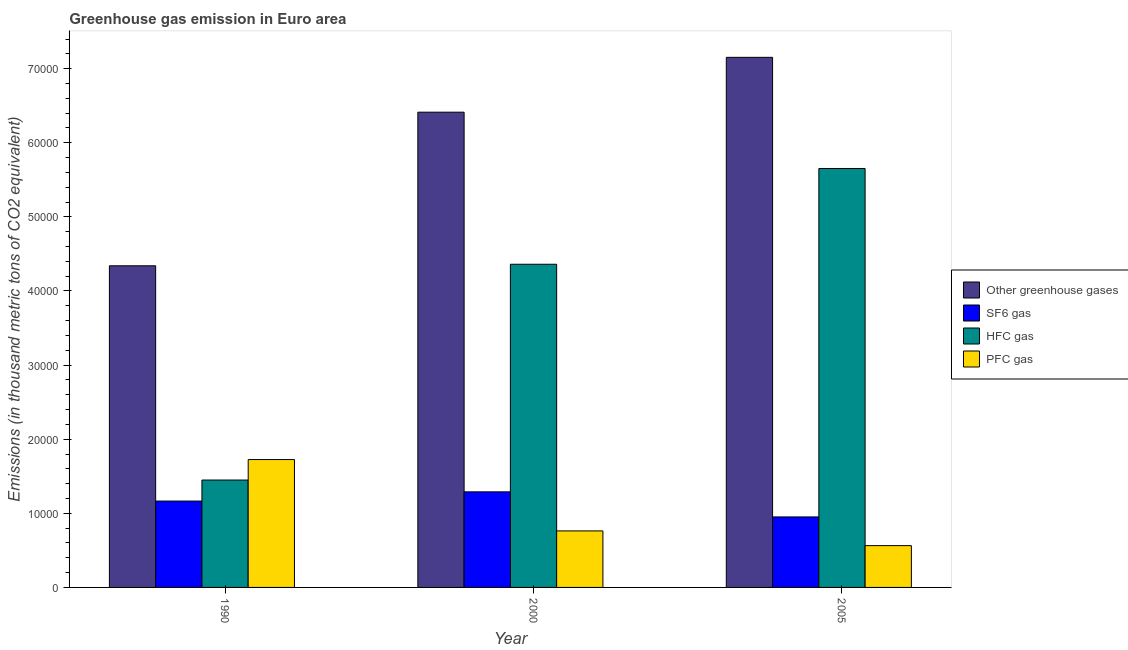Are the number of bars per tick equal to the number of legend labels?
Your answer should be compact. Yes. Are the number of bars on each tick of the X-axis equal?
Keep it short and to the point. Yes. What is the label of the 1st group of bars from the left?
Provide a succinct answer. 1990. In how many cases, is the number of bars for a given year not equal to the number of legend labels?
Your response must be concise. 0. What is the emission of hfc gas in 1990?
Your response must be concise. 1.45e+04. Across all years, what is the maximum emission of greenhouse gases?
Your answer should be very brief. 7.15e+04. Across all years, what is the minimum emission of greenhouse gases?
Your response must be concise. 4.34e+04. In which year was the emission of pfc gas maximum?
Your answer should be compact. 1990. In which year was the emission of hfc gas minimum?
Make the answer very short. 1990. What is the total emission of sf6 gas in the graph?
Provide a succinct answer. 3.41e+04. What is the difference between the emission of sf6 gas in 1990 and that in 2005?
Ensure brevity in your answer.  2140.88. What is the difference between the emission of greenhouse gases in 2005 and the emission of pfc gas in 1990?
Your answer should be compact. 2.81e+04. What is the average emission of greenhouse gases per year?
Your answer should be very brief. 5.97e+04. In how many years, is the emission of pfc gas greater than 22000 thousand metric tons?
Your answer should be very brief. 0. What is the ratio of the emission of sf6 gas in 1990 to that in 2000?
Keep it short and to the point. 0.9. Is the emission of hfc gas in 1990 less than that in 2000?
Offer a terse response. Yes. Is the difference between the emission of hfc gas in 1990 and 2005 greater than the difference between the emission of pfc gas in 1990 and 2005?
Your response must be concise. No. What is the difference between the highest and the second highest emission of hfc gas?
Provide a short and direct response. 1.29e+04. What is the difference between the highest and the lowest emission of greenhouse gases?
Your response must be concise. 2.81e+04. In how many years, is the emission of pfc gas greater than the average emission of pfc gas taken over all years?
Provide a short and direct response. 1. What does the 2nd bar from the left in 2000 represents?
Offer a terse response. SF6 gas. What does the 2nd bar from the right in 2005 represents?
Keep it short and to the point. HFC gas. How many years are there in the graph?
Your answer should be compact. 3. Does the graph contain any zero values?
Provide a short and direct response. No. Does the graph contain grids?
Give a very brief answer. No. Where does the legend appear in the graph?
Provide a succinct answer. Center right. How are the legend labels stacked?
Give a very brief answer. Vertical. What is the title of the graph?
Offer a terse response. Greenhouse gas emission in Euro area. Does "Public resource use" appear as one of the legend labels in the graph?
Make the answer very short. No. What is the label or title of the X-axis?
Offer a terse response. Year. What is the label or title of the Y-axis?
Keep it short and to the point. Emissions (in thousand metric tons of CO2 equivalent). What is the Emissions (in thousand metric tons of CO2 equivalent) in Other greenhouse gases in 1990?
Your response must be concise. 4.34e+04. What is the Emissions (in thousand metric tons of CO2 equivalent) of SF6 gas in 1990?
Ensure brevity in your answer.  1.17e+04. What is the Emissions (in thousand metric tons of CO2 equivalent) of HFC gas in 1990?
Offer a terse response. 1.45e+04. What is the Emissions (in thousand metric tons of CO2 equivalent) in PFC gas in 1990?
Your response must be concise. 1.73e+04. What is the Emissions (in thousand metric tons of CO2 equivalent) of Other greenhouse gases in 2000?
Your answer should be very brief. 6.41e+04. What is the Emissions (in thousand metric tons of CO2 equivalent) in SF6 gas in 2000?
Offer a terse response. 1.29e+04. What is the Emissions (in thousand metric tons of CO2 equivalent) of HFC gas in 2000?
Make the answer very short. 4.36e+04. What is the Emissions (in thousand metric tons of CO2 equivalent) of PFC gas in 2000?
Your answer should be very brief. 7625. What is the Emissions (in thousand metric tons of CO2 equivalent) in Other greenhouse gases in 2005?
Provide a short and direct response. 7.15e+04. What is the Emissions (in thousand metric tons of CO2 equivalent) of SF6 gas in 2005?
Offer a very short reply. 9513.72. What is the Emissions (in thousand metric tons of CO2 equivalent) of HFC gas in 2005?
Your response must be concise. 5.65e+04. What is the Emissions (in thousand metric tons of CO2 equivalent) in PFC gas in 2005?
Provide a succinct answer. 5640.06. Across all years, what is the maximum Emissions (in thousand metric tons of CO2 equivalent) of Other greenhouse gases?
Provide a short and direct response. 7.15e+04. Across all years, what is the maximum Emissions (in thousand metric tons of CO2 equivalent) of SF6 gas?
Make the answer very short. 1.29e+04. Across all years, what is the maximum Emissions (in thousand metric tons of CO2 equivalent) in HFC gas?
Offer a very short reply. 5.65e+04. Across all years, what is the maximum Emissions (in thousand metric tons of CO2 equivalent) of PFC gas?
Offer a very short reply. 1.73e+04. Across all years, what is the minimum Emissions (in thousand metric tons of CO2 equivalent) in Other greenhouse gases?
Offer a very short reply. 4.34e+04. Across all years, what is the minimum Emissions (in thousand metric tons of CO2 equivalent) of SF6 gas?
Offer a very short reply. 9513.72. Across all years, what is the minimum Emissions (in thousand metric tons of CO2 equivalent) in HFC gas?
Provide a succinct answer. 1.45e+04. Across all years, what is the minimum Emissions (in thousand metric tons of CO2 equivalent) in PFC gas?
Keep it short and to the point. 5640.06. What is the total Emissions (in thousand metric tons of CO2 equivalent) in Other greenhouse gases in the graph?
Your answer should be very brief. 1.79e+05. What is the total Emissions (in thousand metric tons of CO2 equivalent) in SF6 gas in the graph?
Offer a very short reply. 3.41e+04. What is the total Emissions (in thousand metric tons of CO2 equivalent) of HFC gas in the graph?
Your answer should be very brief. 1.15e+05. What is the total Emissions (in thousand metric tons of CO2 equivalent) in PFC gas in the graph?
Offer a very short reply. 3.05e+04. What is the difference between the Emissions (in thousand metric tons of CO2 equivalent) of Other greenhouse gases in 1990 and that in 2000?
Offer a very short reply. -2.07e+04. What is the difference between the Emissions (in thousand metric tons of CO2 equivalent) in SF6 gas in 1990 and that in 2000?
Offer a very short reply. -1242.6. What is the difference between the Emissions (in thousand metric tons of CO2 equivalent) in HFC gas in 1990 and that in 2000?
Offer a terse response. -2.91e+04. What is the difference between the Emissions (in thousand metric tons of CO2 equivalent) in PFC gas in 1990 and that in 2000?
Offer a very short reply. 9630.1. What is the difference between the Emissions (in thousand metric tons of CO2 equivalent) in Other greenhouse gases in 1990 and that in 2005?
Your response must be concise. -2.81e+04. What is the difference between the Emissions (in thousand metric tons of CO2 equivalent) of SF6 gas in 1990 and that in 2005?
Keep it short and to the point. 2140.88. What is the difference between the Emissions (in thousand metric tons of CO2 equivalent) of HFC gas in 1990 and that in 2005?
Offer a very short reply. -4.20e+04. What is the difference between the Emissions (in thousand metric tons of CO2 equivalent) of PFC gas in 1990 and that in 2005?
Offer a terse response. 1.16e+04. What is the difference between the Emissions (in thousand metric tons of CO2 equivalent) of Other greenhouse gases in 2000 and that in 2005?
Provide a succinct answer. -7401.3. What is the difference between the Emissions (in thousand metric tons of CO2 equivalent) in SF6 gas in 2000 and that in 2005?
Keep it short and to the point. 3383.48. What is the difference between the Emissions (in thousand metric tons of CO2 equivalent) of HFC gas in 2000 and that in 2005?
Ensure brevity in your answer.  -1.29e+04. What is the difference between the Emissions (in thousand metric tons of CO2 equivalent) of PFC gas in 2000 and that in 2005?
Offer a terse response. 1984.94. What is the difference between the Emissions (in thousand metric tons of CO2 equivalent) of Other greenhouse gases in 1990 and the Emissions (in thousand metric tons of CO2 equivalent) of SF6 gas in 2000?
Ensure brevity in your answer.  3.05e+04. What is the difference between the Emissions (in thousand metric tons of CO2 equivalent) of Other greenhouse gases in 1990 and the Emissions (in thousand metric tons of CO2 equivalent) of HFC gas in 2000?
Give a very brief answer. -206.3. What is the difference between the Emissions (in thousand metric tons of CO2 equivalent) in Other greenhouse gases in 1990 and the Emissions (in thousand metric tons of CO2 equivalent) in PFC gas in 2000?
Your response must be concise. 3.58e+04. What is the difference between the Emissions (in thousand metric tons of CO2 equivalent) in SF6 gas in 1990 and the Emissions (in thousand metric tons of CO2 equivalent) in HFC gas in 2000?
Give a very brief answer. -3.20e+04. What is the difference between the Emissions (in thousand metric tons of CO2 equivalent) in SF6 gas in 1990 and the Emissions (in thousand metric tons of CO2 equivalent) in PFC gas in 2000?
Offer a very short reply. 4029.6. What is the difference between the Emissions (in thousand metric tons of CO2 equivalent) in HFC gas in 1990 and the Emissions (in thousand metric tons of CO2 equivalent) in PFC gas in 2000?
Make the answer very short. 6866.6. What is the difference between the Emissions (in thousand metric tons of CO2 equivalent) of Other greenhouse gases in 1990 and the Emissions (in thousand metric tons of CO2 equivalent) of SF6 gas in 2005?
Make the answer very short. 3.39e+04. What is the difference between the Emissions (in thousand metric tons of CO2 equivalent) of Other greenhouse gases in 1990 and the Emissions (in thousand metric tons of CO2 equivalent) of HFC gas in 2005?
Your response must be concise. -1.31e+04. What is the difference between the Emissions (in thousand metric tons of CO2 equivalent) of Other greenhouse gases in 1990 and the Emissions (in thousand metric tons of CO2 equivalent) of PFC gas in 2005?
Provide a short and direct response. 3.78e+04. What is the difference between the Emissions (in thousand metric tons of CO2 equivalent) of SF6 gas in 1990 and the Emissions (in thousand metric tons of CO2 equivalent) of HFC gas in 2005?
Your answer should be very brief. -4.49e+04. What is the difference between the Emissions (in thousand metric tons of CO2 equivalent) of SF6 gas in 1990 and the Emissions (in thousand metric tons of CO2 equivalent) of PFC gas in 2005?
Your response must be concise. 6014.54. What is the difference between the Emissions (in thousand metric tons of CO2 equivalent) in HFC gas in 1990 and the Emissions (in thousand metric tons of CO2 equivalent) in PFC gas in 2005?
Give a very brief answer. 8851.54. What is the difference between the Emissions (in thousand metric tons of CO2 equivalent) in Other greenhouse gases in 2000 and the Emissions (in thousand metric tons of CO2 equivalent) in SF6 gas in 2005?
Your response must be concise. 5.46e+04. What is the difference between the Emissions (in thousand metric tons of CO2 equivalent) in Other greenhouse gases in 2000 and the Emissions (in thousand metric tons of CO2 equivalent) in HFC gas in 2005?
Make the answer very short. 7598.1. What is the difference between the Emissions (in thousand metric tons of CO2 equivalent) of Other greenhouse gases in 2000 and the Emissions (in thousand metric tons of CO2 equivalent) of PFC gas in 2005?
Provide a short and direct response. 5.85e+04. What is the difference between the Emissions (in thousand metric tons of CO2 equivalent) of SF6 gas in 2000 and the Emissions (in thousand metric tons of CO2 equivalent) of HFC gas in 2005?
Provide a short and direct response. -4.36e+04. What is the difference between the Emissions (in thousand metric tons of CO2 equivalent) in SF6 gas in 2000 and the Emissions (in thousand metric tons of CO2 equivalent) in PFC gas in 2005?
Give a very brief answer. 7257.14. What is the difference between the Emissions (in thousand metric tons of CO2 equivalent) of HFC gas in 2000 and the Emissions (in thousand metric tons of CO2 equivalent) of PFC gas in 2005?
Your answer should be very brief. 3.80e+04. What is the average Emissions (in thousand metric tons of CO2 equivalent) in Other greenhouse gases per year?
Provide a succinct answer. 5.97e+04. What is the average Emissions (in thousand metric tons of CO2 equivalent) in SF6 gas per year?
Your response must be concise. 1.14e+04. What is the average Emissions (in thousand metric tons of CO2 equivalent) of HFC gas per year?
Give a very brief answer. 3.82e+04. What is the average Emissions (in thousand metric tons of CO2 equivalent) of PFC gas per year?
Give a very brief answer. 1.02e+04. In the year 1990, what is the difference between the Emissions (in thousand metric tons of CO2 equivalent) of Other greenhouse gases and Emissions (in thousand metric tons of CO2 equivalent) of SF6 gas?
Provide a succinct answer. 3.17e+04. In the year 1990, what is the difference between the Emissions (in thousand metric tons of CO2 equivalent) in Other greenhouse gases and Emissions (in thousand metric tons of CO2 equivalent) in HFC gas?
Ensure brevity in your answer.  2.89e+04. In the year 1990, what is the difference between the Emissions (in thousand metric tons of CO2 equivalent) in Other greenhouse gases and Emissions (in thousand metric tons of CO2 equivalent) in PFC gas?
Ensure brevity in your answer.  2.61e+04. In the year 1990, what is the difference between the Emissions (in thousand metric tons of CO2 equivalent) of SF6 gas and Emissions (in thousand metric tons of CO2 equivalent) of HFC gas?
Give a very brief answer. -2837. In the year 1990, what is the difference between the Emissions (in thousand metric tons of CO2 equivalent) of SF6 gas and Emissions (in thousand metric tons of CO2 equivalent) of PFC gas?
Provide a succinct answer. -5600.5. In the year 1990, what is the difference between the Emissions (in thousand metric tons of CO2 equivalent) of HFC gas and Emissions (in thousand metric tons of CO2 equivalent) of PFC gas?
Keep it short and to the point. -2763.5. In the year 2000, what is the difference between the Emissions (in thousand metric tons of CO2 equivalent) of Other greenhouse gases and Emissions (in thousand metric tons of CO2 equivalent) of SF6 gas?
Provide a short and direct response. 5.12e+04. In the year 2000, what is the difference between the Emissions (in thousand metric tons of CO2 equivalent) of Other greenhouse gases and Emissions (in thousand metric tons of CO2 equivalent) of HFC gas?
Offer a very short reply. 2.05e+04. In the year 2000, what is the difference between the Emissions (in thousand metric tons of CO2 equivalent) in Other greenhouse gases and Emissions (in thousand metric tons of CO2 equivalent) in PFC gas?
Make the answer very short. 5.65e+04. In the year 2000, what is the difference between the Emissions (in thousand metric tons of CO2 equivalent) in SF6 gas and Emissions (in thousand metric tons of CO2 equivalent) in HFC gas?
Provide a succinct answer. -3.07e+04. In the year 2000, what is the difference between the Emissions (in thousand metric tons of CO2 equivalent) of SF6 gas and Emissions (in thousand metric tons of CO2 equivalent) of PFC gas?
Your answer should be very brief. 5272.2. In the year 2000, what is the difference between the Emissions (in thousand metric tons of CO2 equivalent) of HFC gas and Emissions (in thousand metric tons of CO2 equivalent) of PFC gas?
Offer a terse response. 3.60e+04. In the year 2005, what is the difference between the Emissions (in thousand metric tons of CO2 equivalent) of Other greenhouse gases and Emissions (in thousand metric tons of CO2 equivalent) of SF6 gas?
Offer a very short reply. 6.20e+04. In the year 2005, what is the difference between the Emissions (in thousand metric tons of CO2 equivalent) of Other greenhouse gases and Emissions (in thousand metric tons of CO2 equivalent) of HFC gas?
Offer a terse response. 1.50e+04. In the year 2005, what is the difference between the Emissions (in thousand metric tons of CO2 equivalent) in Other greenhouse gases and Emissions (in thousand metric tons of CO2 equivalent) in PFC gas?
Make the answer very short. 6.59e+04. In the year 2005, what is the difference between the Emissions (in thousand metric tons of CO2 equivalent) in SF6 gas and Emissions (in thousand metric tons of CO2 equivalent) in HFC gas?
Your response must be concise. -4.70e+04. In the year 2005, what is the difference between the Emissions (in thousand metric tons of CO2 equivalent) of SF6 gas and Emissions (in thousand metric tons of CO2 equivalent) of PFC gas?
Keep it short and to the point. 3873.66. In the year 2005, what is the difference between the Emissions (in thousand metric tons of CO2 equivalent) in HFC gas and Emissions (in thousand metric tons of CO2 equivalent) in PFC gas?
Keep it short and to the point. 5.09e+04. What is the ratio of the Emissions (in thousand metric tons of CO2 equivalent) in Other greenhouse gases in 1990 to that in 2000?
Provide a short and direct response. 0.68. What is the ratio of the Emissions (in thousand metric tons of CO2 equivalent) in SF6 gas in 1990 to that in 2000?
Give a very brief answer. 0.9. What is the ratio of the Emissions (in thousand metric tons of CO2 equivalent) of HFC gas in 1990 to that in 2000?
Keep it short and to the point. 0.33. What is the ratio of the Emissions (in thousand metric tons of CO2 equivalent) of PFC gas in 1990 to that in 2000?
Give a very brief answer. 2.26. What is the ratio of the Emissions (in thousand metric tons of CO2 equivalent) of Other greenhouse gases in 1990 to that in 2005?
Make the answer very short. 0.61. What is the ratio of the Emissions (in thousand metric tons of CO2 equivalent) in SF6 gas in 1990 to that in 2005?
Offer a very short reply. 1.23. What is the ratio of the Emissions (in thousand metric tons of CO2 equivalent) in HFC gas in 1990 to that in 2005?
Make the answer very short. 0.26. What is the ratio of the Emissions (in thousand metric tons of CO2 equivalent) in PFC gas in 1990 to that in 2005?
Ensure brevity in your answer.  3.06. What is the ratio of the Emissions (in thousand metric tons of CO2 equivalent) in Other greenhouse gases in 2000 to that in 2005?
Your answer should be compact. 0.9. What is the ratio of the Emissions (in thousand metric tons of CO2 equivalent) in SF6 gas in 2000 to that in 2005?
Offer a terse response. 1.36. What is the ratio of the Emissions (in thousand metric tons of CO2 equivalent) of HFC gas in 2000 to that in 2005?
Ensure brevity in your answer.  0.77. What is the ratio of the Emissions (in thousand metric tons of CO2 equivalent) of PFC gas in 2000 to that in 2005?
Your answer should be compact. 1.35. What is the difference between the highest and the second highest Emissions (in thousand metric tons of CO2 equivalent) of Other greenhouse gases?
Your answer should be very brief. 7401.3. What is the difference between the highest and the second highest Emissions (in thousand metric tons of CO2 equivalent) in SF6 gas?
Your answer should be very brief. 1242.6. What is the difference between the highest and the second highest Emissions (in thousand metric tons of CO2 equivalent) in HFC gas?
Provide a short and direct response. 1.29e+04. What is the difference between the highest and the second highest Emissions (in thousand metric tons of CO2 equivalent) in PFC gas?
Keep it short and to the point. 9630.1. What is the difference between the highest and the lowest Emissions (in thousand metric tons of CO2 equivalent) in Other greenhouse gases?
Keep it short and to the point. 2.81e+04. What is the difference between the highest and the lowest Emissions (in thousand metric tons of CO2 equivalent) of SF6 gas?
Your answer should be very brief. 3383.48. What is the difference between the highest and the lowest Emissions (in thousand metric tons of CO2 equivalent) of HFC gas?
Ensure brevity in your answer.  4.20e+04. What is the difference between the highest and the lowest Emissions (in thousand metric tons of CO2 equivalent) of PFC gas?
Your answer should be very brief. 1.16e+04. 